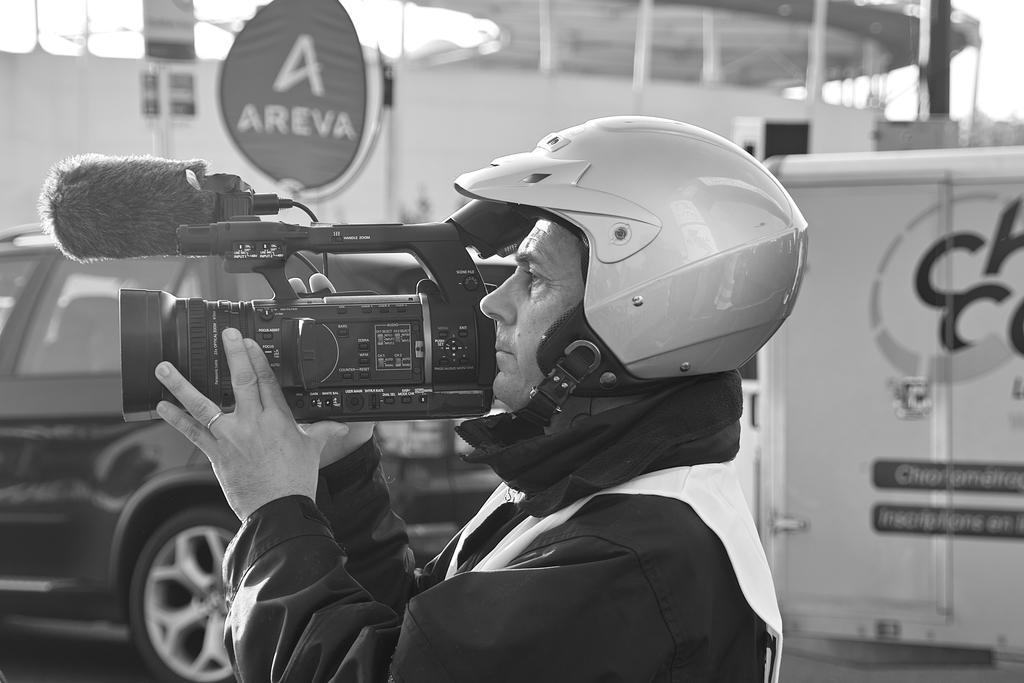How would you summarize this image in a sentence or two? This is a black and white image. We can see a person holding some object. We can see a vehicle and some objects on the right. We can also see some boards and some objects at the top. 